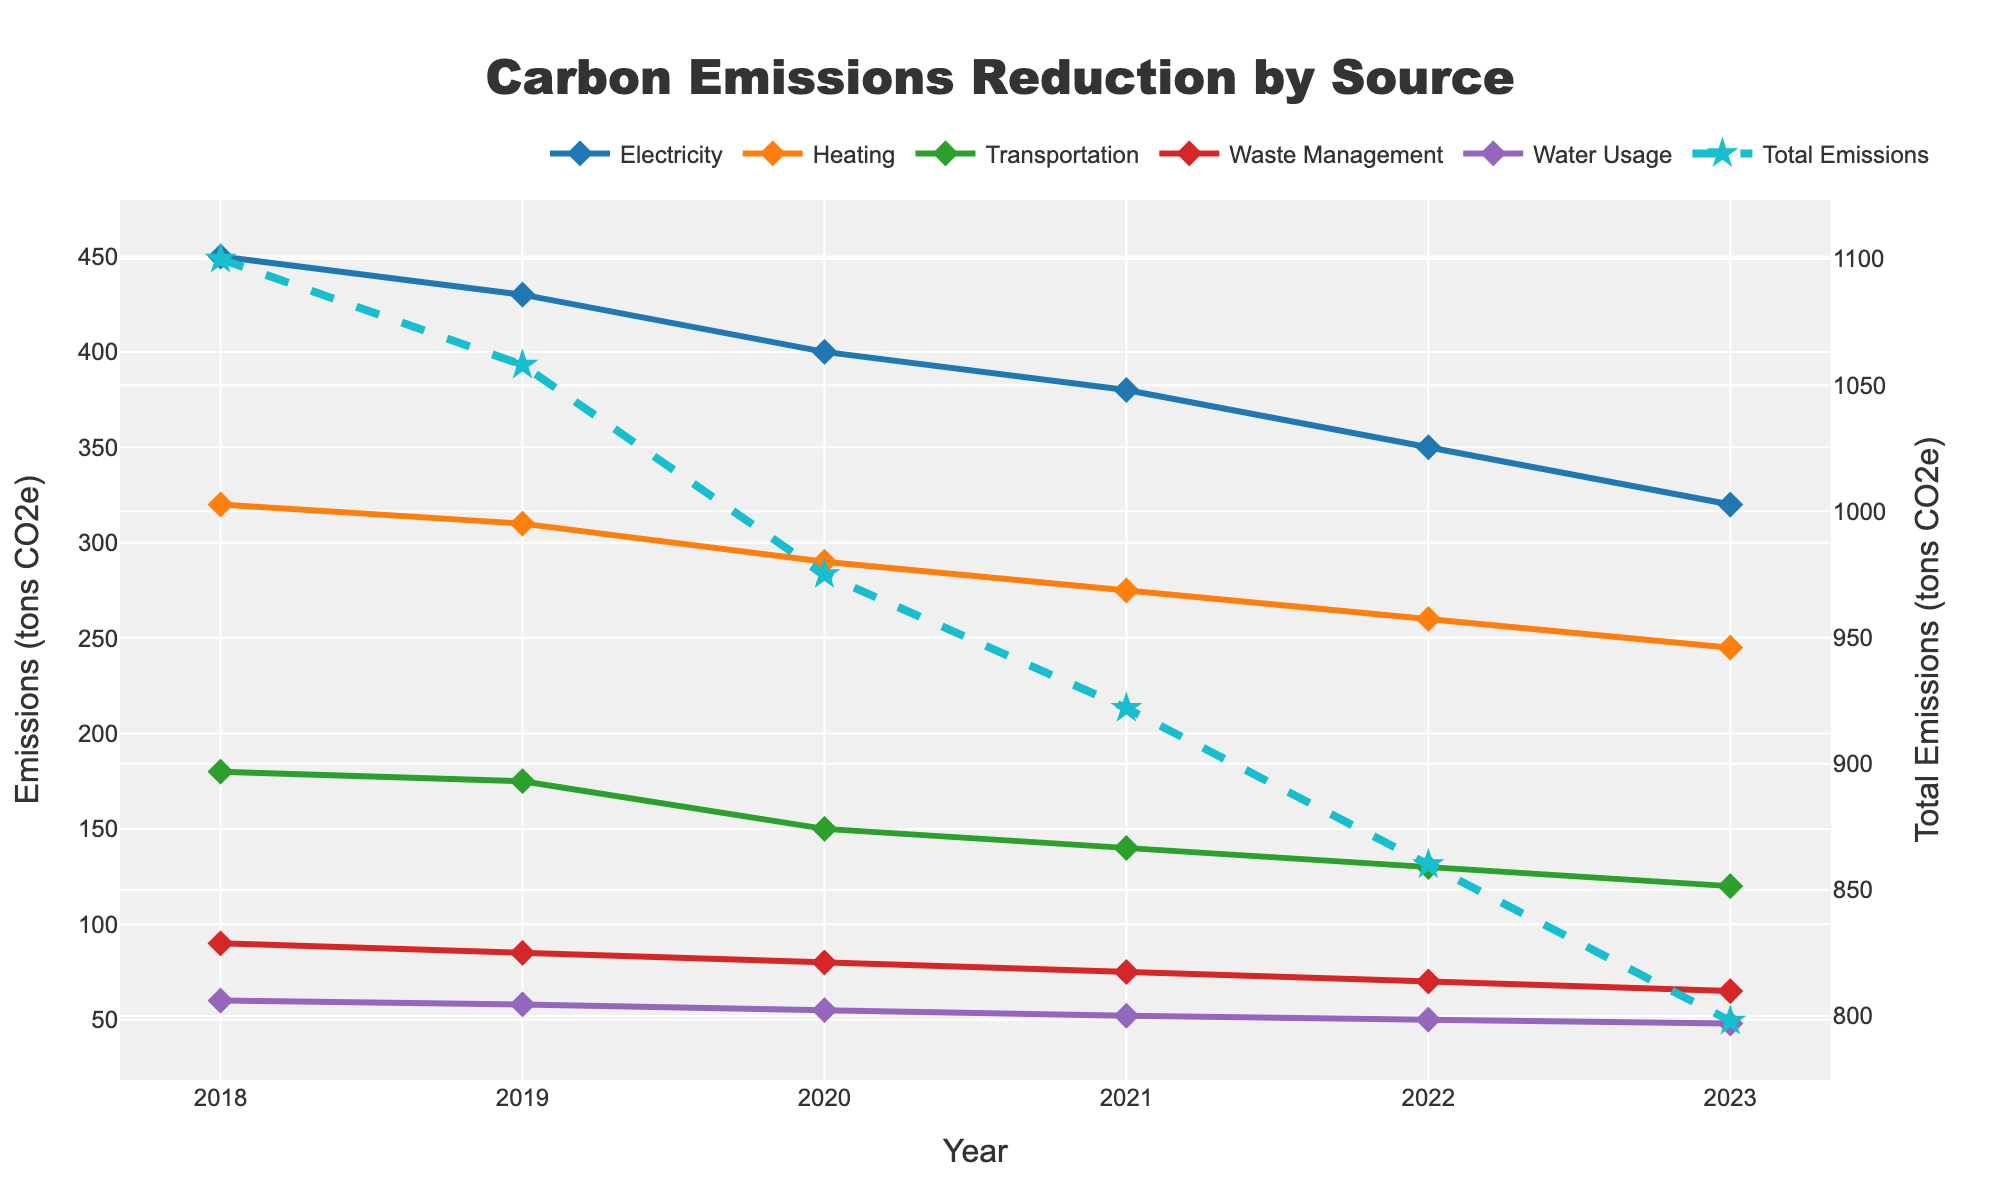Which emission source had the largest reduction in emissions from 2018 to 2023? First, determine the emission levels for each source in 2018 and 2023. Subtract the 2023 emission from the 2018 emission for each source: Electricity (450-320=130), Heating (320-245=75), Transportation (180-120=60), Waste Management (90-65=25), Water Usage (60-48=12). The largest reduction is from Electricity.
Answer: Electricity Which year had the highest total emissions? Calculate the total emissions for each year by summing the emissions of all sources. Compare the total emissions for all years: 2018 (450+320+180+90+60=1100), 2019 (430+310+175+85+58=1058), 2020 (400+290+150+80+55=975), 2021 (380+275+140+75+52=922), 2022 (350+260+130+70+50=860), 2023 (320+245+120+65+48=798). The highest total emissions were in 2018.
Answer: 2018 By how many tons did the Heating emissions decrease between 2019 and 2022? Find the Heating emissions for 2019 and 2022 from the data: 2019 (310), 2022 (260). Subtract the 2022 emission from the 2019 emission: 310 - 260 = 50.
Answer: 50 What is the trend in Water Usage emissions from 2018 to 2023? Examine the Water Usage emissions for each year: 2018 (60), 2019 (58), 2020 (55), 2021 (52), 2022 (50), 2023 (48). The trend shows a year-over-year decrease.
Answer: Decreasing Which emissions source had the smallest change overall from 2018 to 2023? Calculate the change for each source by subtracting the 2023 value from the 2018 value: Electricity (130), Heating (75), Transportation (60), Waste Management (25), Water Usage (12). The smallest change is in Water Usage.
Answer: Water Usage Which emission source had the largest reduction from 2019 to 2020? Calculate the difference for each source between 2019 and 2020: Electricity (430-400=30), Heating (310-290=20), Transportation (175-150=25), Waste Management (85-80=5), Water Usage (58-55=3). The largest reduction occurred in Electricity.
Answer: Electricity In which year do Waste Management emissions first drop below 80 tons? Examine the Waste Management emissions by year: 2018 (90), 2019 (85), 2020 (80), 2021 (75). Emissions first drop below 80 tons in 2021.
Answer: 2021 